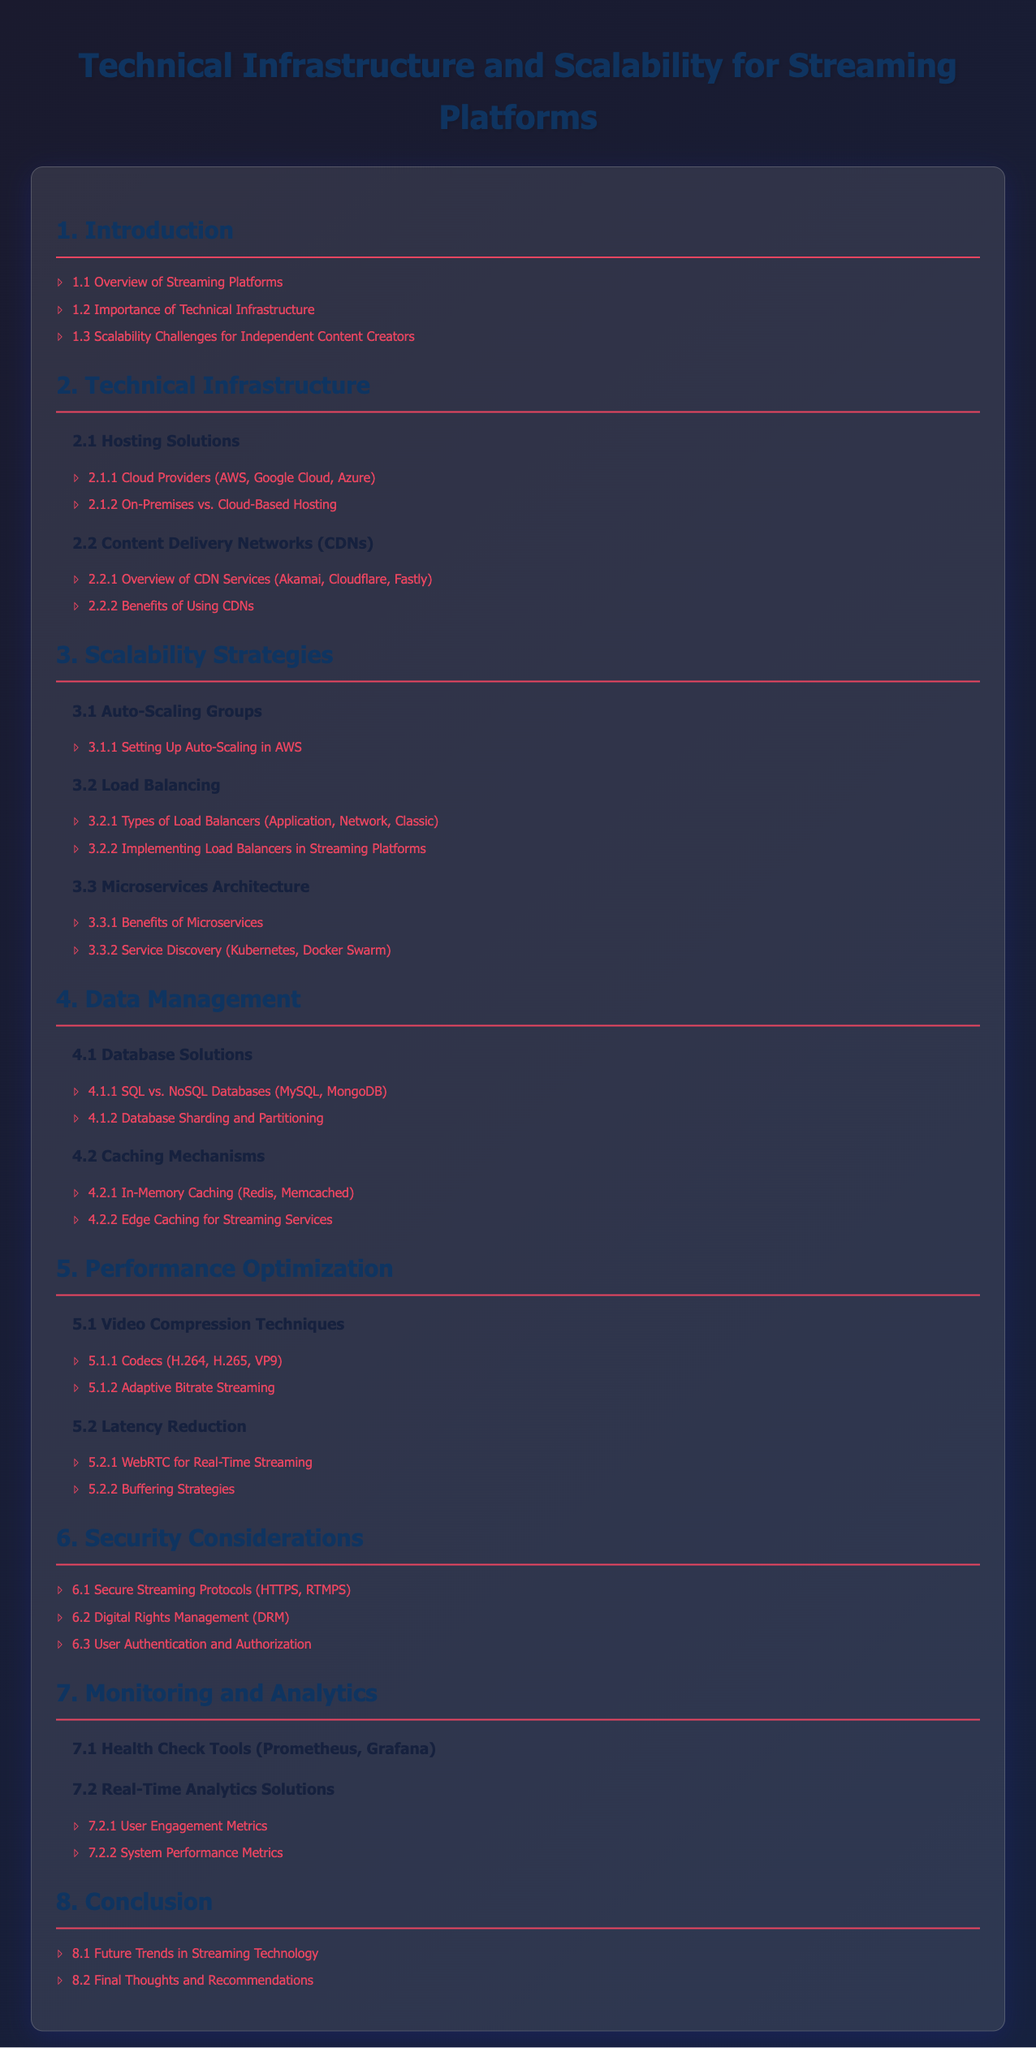What is the title of the document? The title of the document is provided in the `<title>` tag and in the main heading.
Answer: Technical Infrastructure and Scalability for Streaming Platforms What is the first section of the document? The first section is identified by the first `<h2>` tag in the Table of Contents.
Answer: Introduction Which load balancing type is mentioned in the document? The types of load balancers are listed in the subsection under Load Balancing.
Answer: Application, Network, Classic What is mentioned as a benefit of CDNs? The benefits of CDNs are highlighted in their respective subsection under Content Delivery Networks.
Answer: Benefits of Using CDNs How many video compression techniques are listed? The video compression techniques are outlined in subsection 5.1, providing a count of items listed.
Answer: 2 What is the last section in the Table of Contents? The last section is identified by the last `<h2>` tag in the Table of Contents.
Answer: Conclusion Which in-memory caching solutions are listed? The in-memory caching solutions are found in subsection 4.2 of the document.
Answer: Redis, Memcached What kind of database solutions are compared? The comparison of database solutions is specified in subsection 4.1 of the document.
Answer: SQL vs. NoSQL Databases What tool is mentioned for health checks? The health check tools are explicitly mentioned in subsection 7.1.
Answer: Prometheus, Grafana 